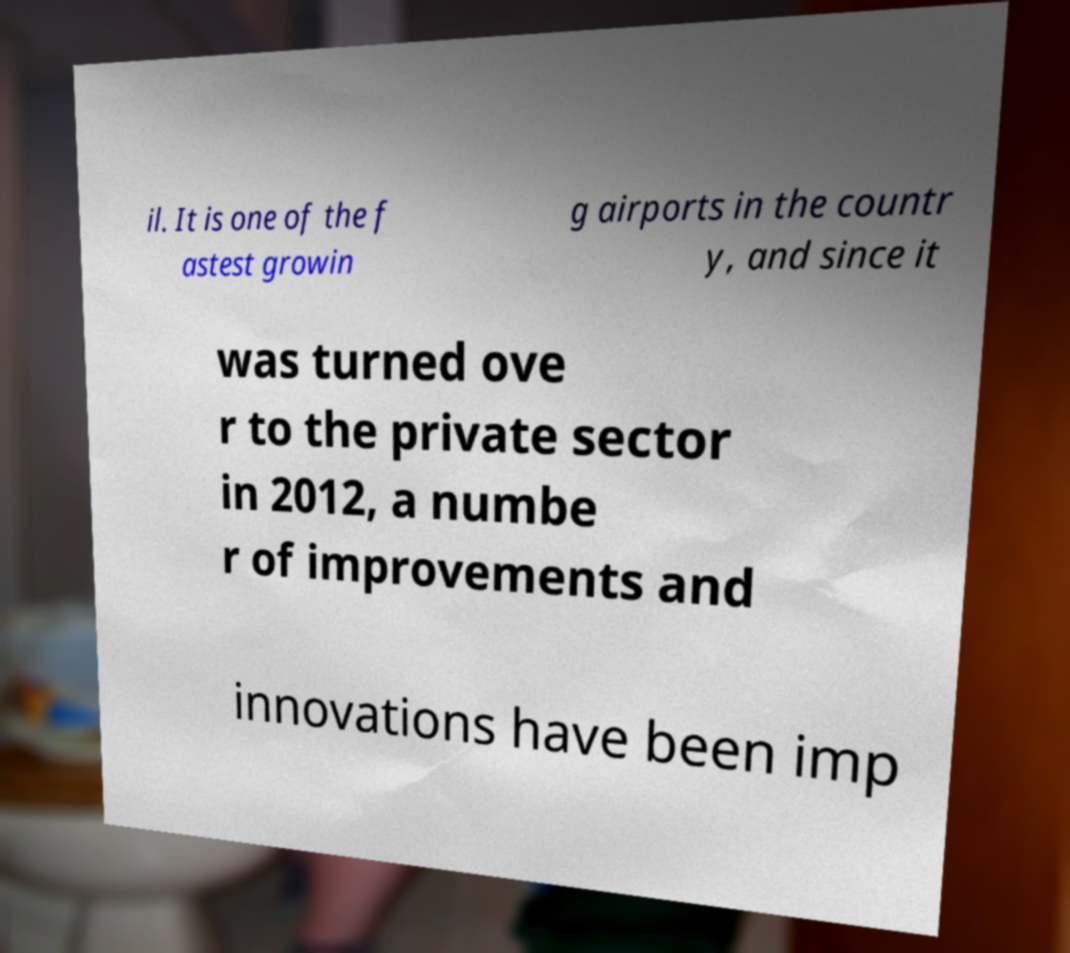Can you accurately transcribe the text from the provided image for me? il. It is one of the f astest growin g airports in the countr y, and since it was turned ove r to the private sector in 2012, a numbe r of improvements and innovations have been imp 